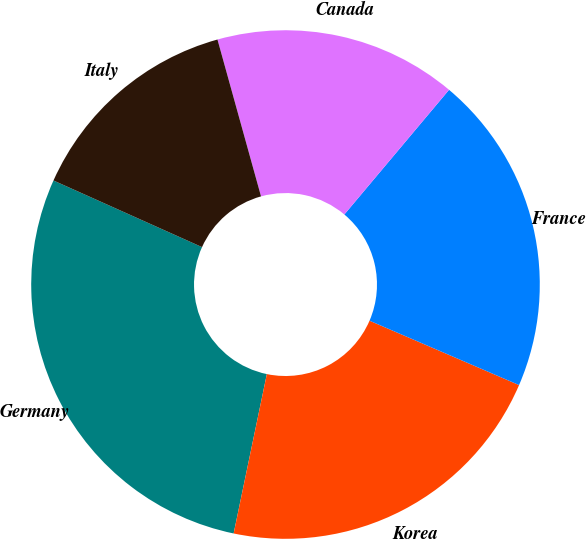Convert chart to OTSL. <chart><loc_0><loc_0><loc_500><loc_500><pie_chart><fcel>Germany<fcel>Korea<fcel>France<fcel>Canada<fcel>Italy<nl><fcel>28.44%<fcel>21.8%<fcel>20.35%<fcel>15.43%<fcel>13.98%<nl></chart> 